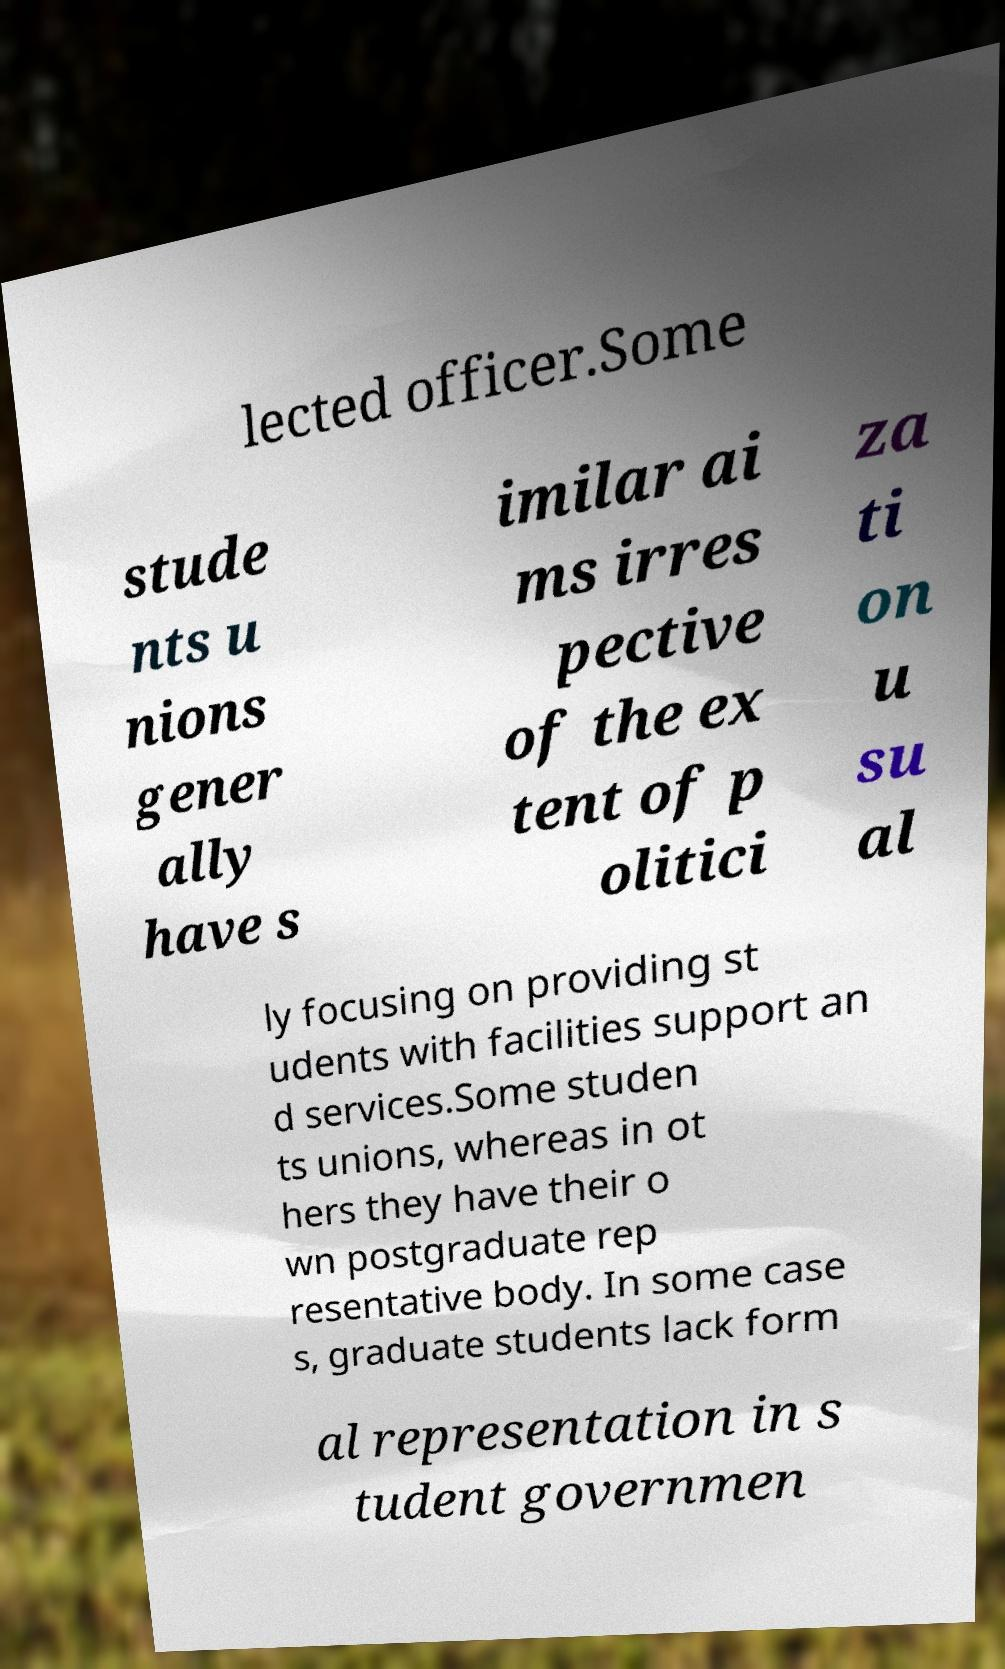I need the written content from this picture converted into text. Can you do that? lected officer.Some stude nts u nions gener ally have s imilar ai ms irres pective of the ex tent of p olitici za ti on u su al ly focusing on providing st udents with facilities support an d services.Some studen ts unions, whereas in ot hers they have their o wn postgraduate rep resentative body. In some case s, graduate students lack form al representation in s tudent governmen 